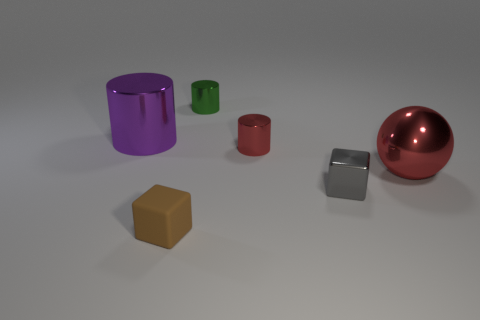How many metal things are in front of the big purple cylinder and to the left of the large red shiny object?
Your response must be concise. 2. Are there any small blocks that are in front of the small brown block that is on the left side of the red object right of the small red thing?
Keep it short and to the point. No. What is the shape of the other object that is the same size as the purple shiny object?
Your answer should be very brief. Sphere. Is there another metal block that has the same color as the metallic block?
Your answer should be very brief. No. Does the gray metallic object have the same shape as the small rubber thing?
Provide a short and direct response. Yes. What number of small objects are purple shiny things or red metal balls?
Keep it short and to the point. 0. The big ball that is the same material as the big purple cylinder is what color?
Offer a terse response. Red. How many tiny brown blocks have the same material as the red cylinder?
Keep it short and to the point. 0. There is a red metal ball that is to the right of the green metallic thing; is its size the same as the red cylinder behind the gray block?
Offer a very short reply. No. There is a red object that is behind the thing to the right of the gray cube; what is its material?
Your answer should be very brief. Metal. 